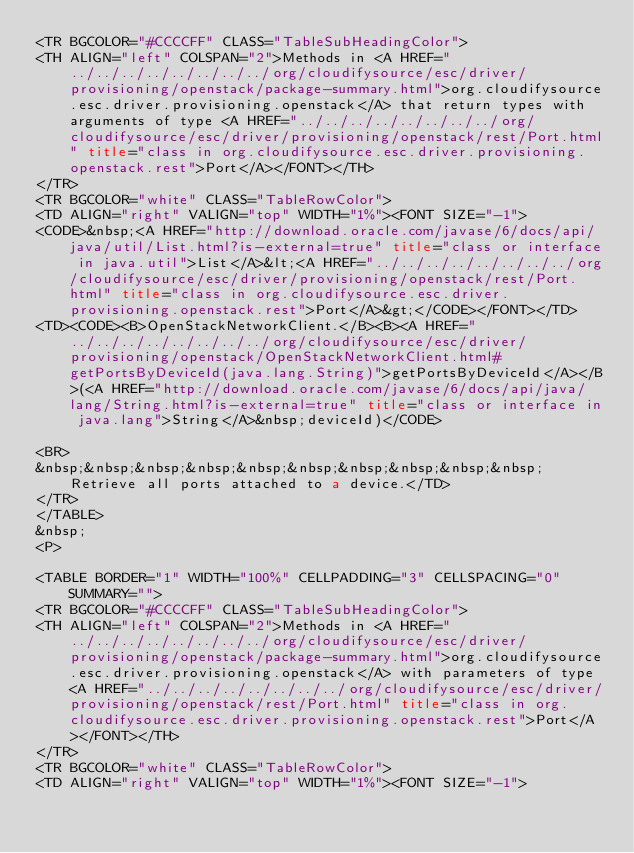<code> <loc_0><loc_0><loc_500><loc_500><_HTML_><TR BGCOLOR="#CCCCFF" CLASS="TableSubHeadingColor">
<TH ALIGN="left" COLSPAN="2">Methods in <A HREF="../../../../../../../../org/cloudifysource/esc/driver/provisioning/openstack/package-summary.html">org.cloudifysource.esc.driver.provisioning.openstack</A> that return types with arguments of type <A HREF="../../../../../../../../org/cloudifysource/esc/driver/provisioning/openstack/rest/Port.html" title="class in org.cloudifysource.esc.driver.provisioning.openstack.rest">Port</A></FONT></TH>
</TR>
<TR BGCOLOR="white" CLASS="TableRowColor">
<TD ALIGN="right" VALIGN="top" WIDTH="1%"><FONT SIZE="-1">
<CODE>&nbsp;<A HREF="http://download.oracle.com/javase/6/docs/api/java/util/List.html?is-external=true" title="class or interface in java.util">List</A>&lt;<A HREF="../../../../../../../../org/cloudifysource/esc/driver/provisioning/openstack/rest/Port.html" title="class in org.cloudifysource.esc.driver.provisioning.openstack.rest">Port</A>&gt;</CODE></FONT></TD>
<TD><CODE><B>OpenStackNetworkClient.</B><B><A HREF="../../../../../../../../org/cloudifysource/esc/driver/provisioning/openstack/OpenStackNetworkClient.html#getPortsByDeviceId(java.lang.String)">getPortsByDeviceId</A></B>(<A HREF="http://download.oracle.com/javase/6/docs/api/java/lang/String.html?is-external=true" title="class or interface in java.lang">String</A>&nbsp;deviceId)</CODE>

<BR>
&nbsp;&nbsp;&nbsp;&nbsp;&nbsp;&nbsp;&nbsp;&nbsp;&nbsp;&nbsp;Retrieve all ports attached to a device.</TD>
</TR>
</TABLE>
&nbsp;
<P>

<TABLE BORDER="1" WIDTH="100%" CELLPADDING="3" CELLSPACING="0" SUMMARY="">
<TR BGCOLOR="#CCCCFF" CLASS="TableSubHeadingColor">
<TH ALIGN="left" COLSPAN="2">Methods in <A HREF="../../../../../../../../org/cloudifysource/esc/driver/provisioning/openstack/package-summary.html">org.cloudifysource.esc.driver.provisioning.openstack</A> with parameters of type <A HREF="../../../../../../../../org/cloudifysource/esc/driver/provisioning/openstack/rest/Port.html" title="class in org.cloudifysource.esc.driver.provisioning.openstack.rest">Port</A></FONT></TH>
</TR>
<TR BGCOLOR="white" CLASS="TableRowColor">
<TD ALIGN="right" VALIGN="top" WIDTH="1%"><FONT SIZE="-1"></code> 